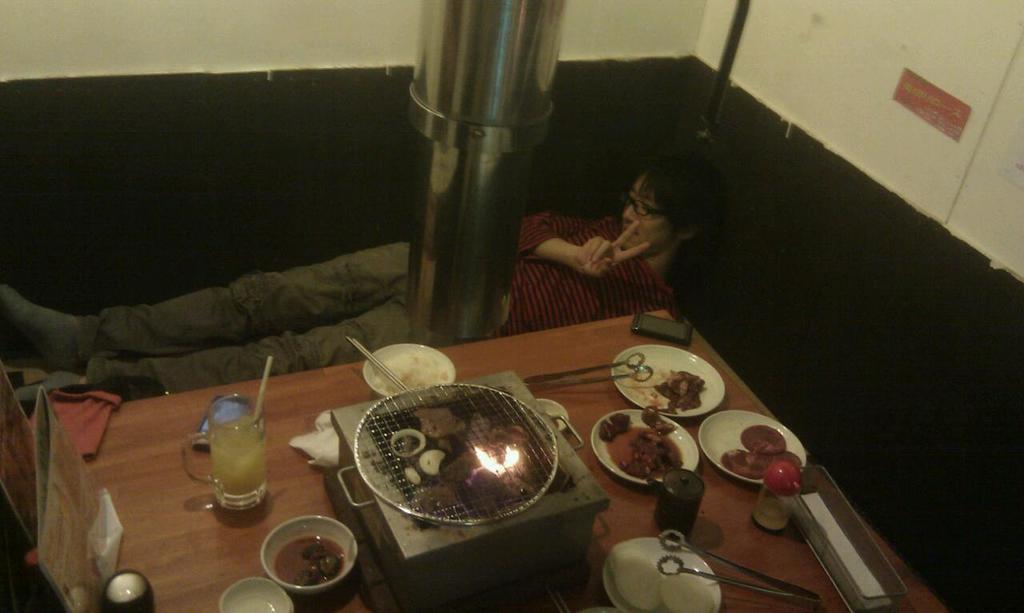Please provide a concise description of this image. A person is sleeping, this person wore spectacles and these are the food items on this dining table. 